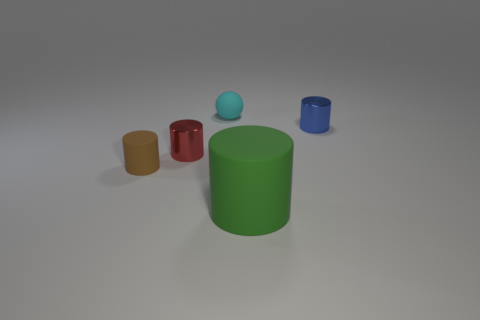Can you describe the lighting and shadows in the scene? The scene is illuminated with soft, diffused lighting coming from the upper right, casting gentle shadows towards the left. The shadows are not overly sharp, suggesting an absence of strong direct light sources. 